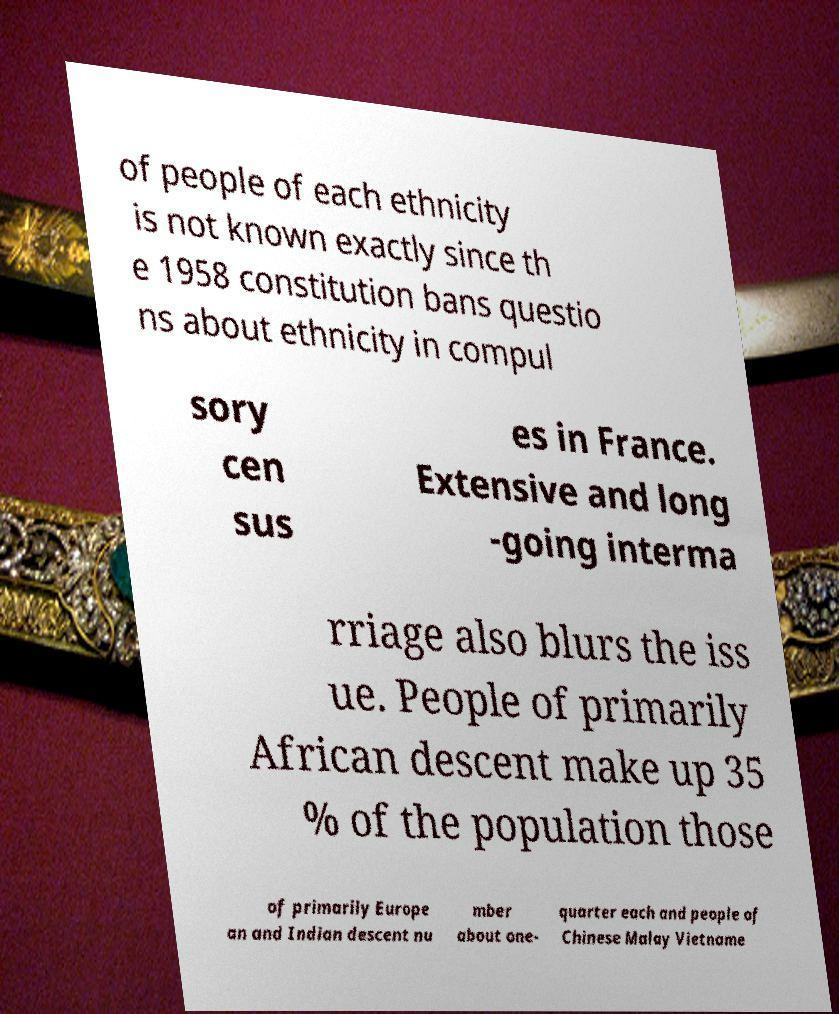Please read and relay the text visible in this image. What does it say? of people of each ethnicity is not known exactly since th e 1958 constitution bans questio ns about ethnicity in compul sory cen sus es in France. Extensive and long -going interma rriage also blurs the iss ue. People of primarily African descent make up 35 % of the population those of primarily Europe an and Indian descent nu mber about one- quarter each and people of Chinese Malay Vietname 